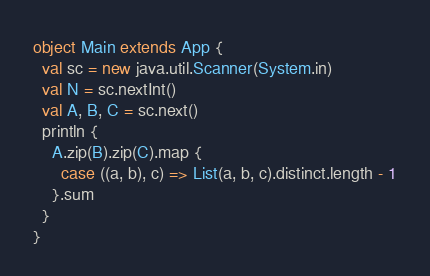Convert code to text. <code><loc_0><loc_0><loc_500><loc_500><_Scala_>object Main extends App {
  val sc = new java.util.Scanner(System.in)
  val N = sc.nextInt()
  val A, B, C = sc.next()
  println {
    A.zip(B).zip(C).map {
      case ((a, b), c) => List(a, b, c).distinct.length - 1
    }.sum
  }
}
</code> 